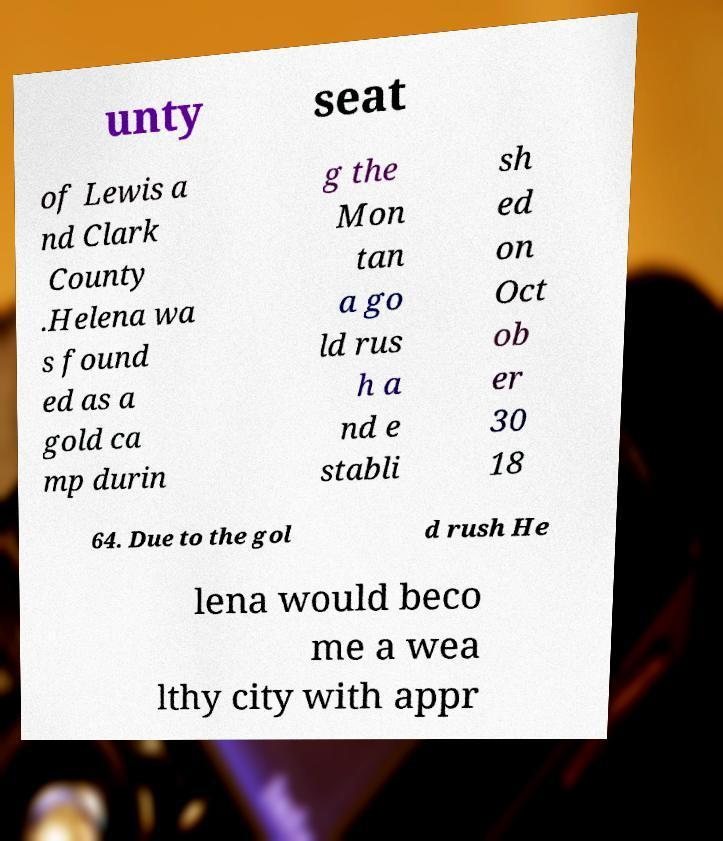What messages or text are displayed in this image? I need them in a readable, typed format. unty seat of Lewis a nd Clark County .Helena wa s found ed as a gold ca mp durin g the Mon tan a go ld rus h a nd e stabli sh ed on Oct ob er 30 18 64. Due to the gol d rush He lena would beco me a wea lthy city with appr 